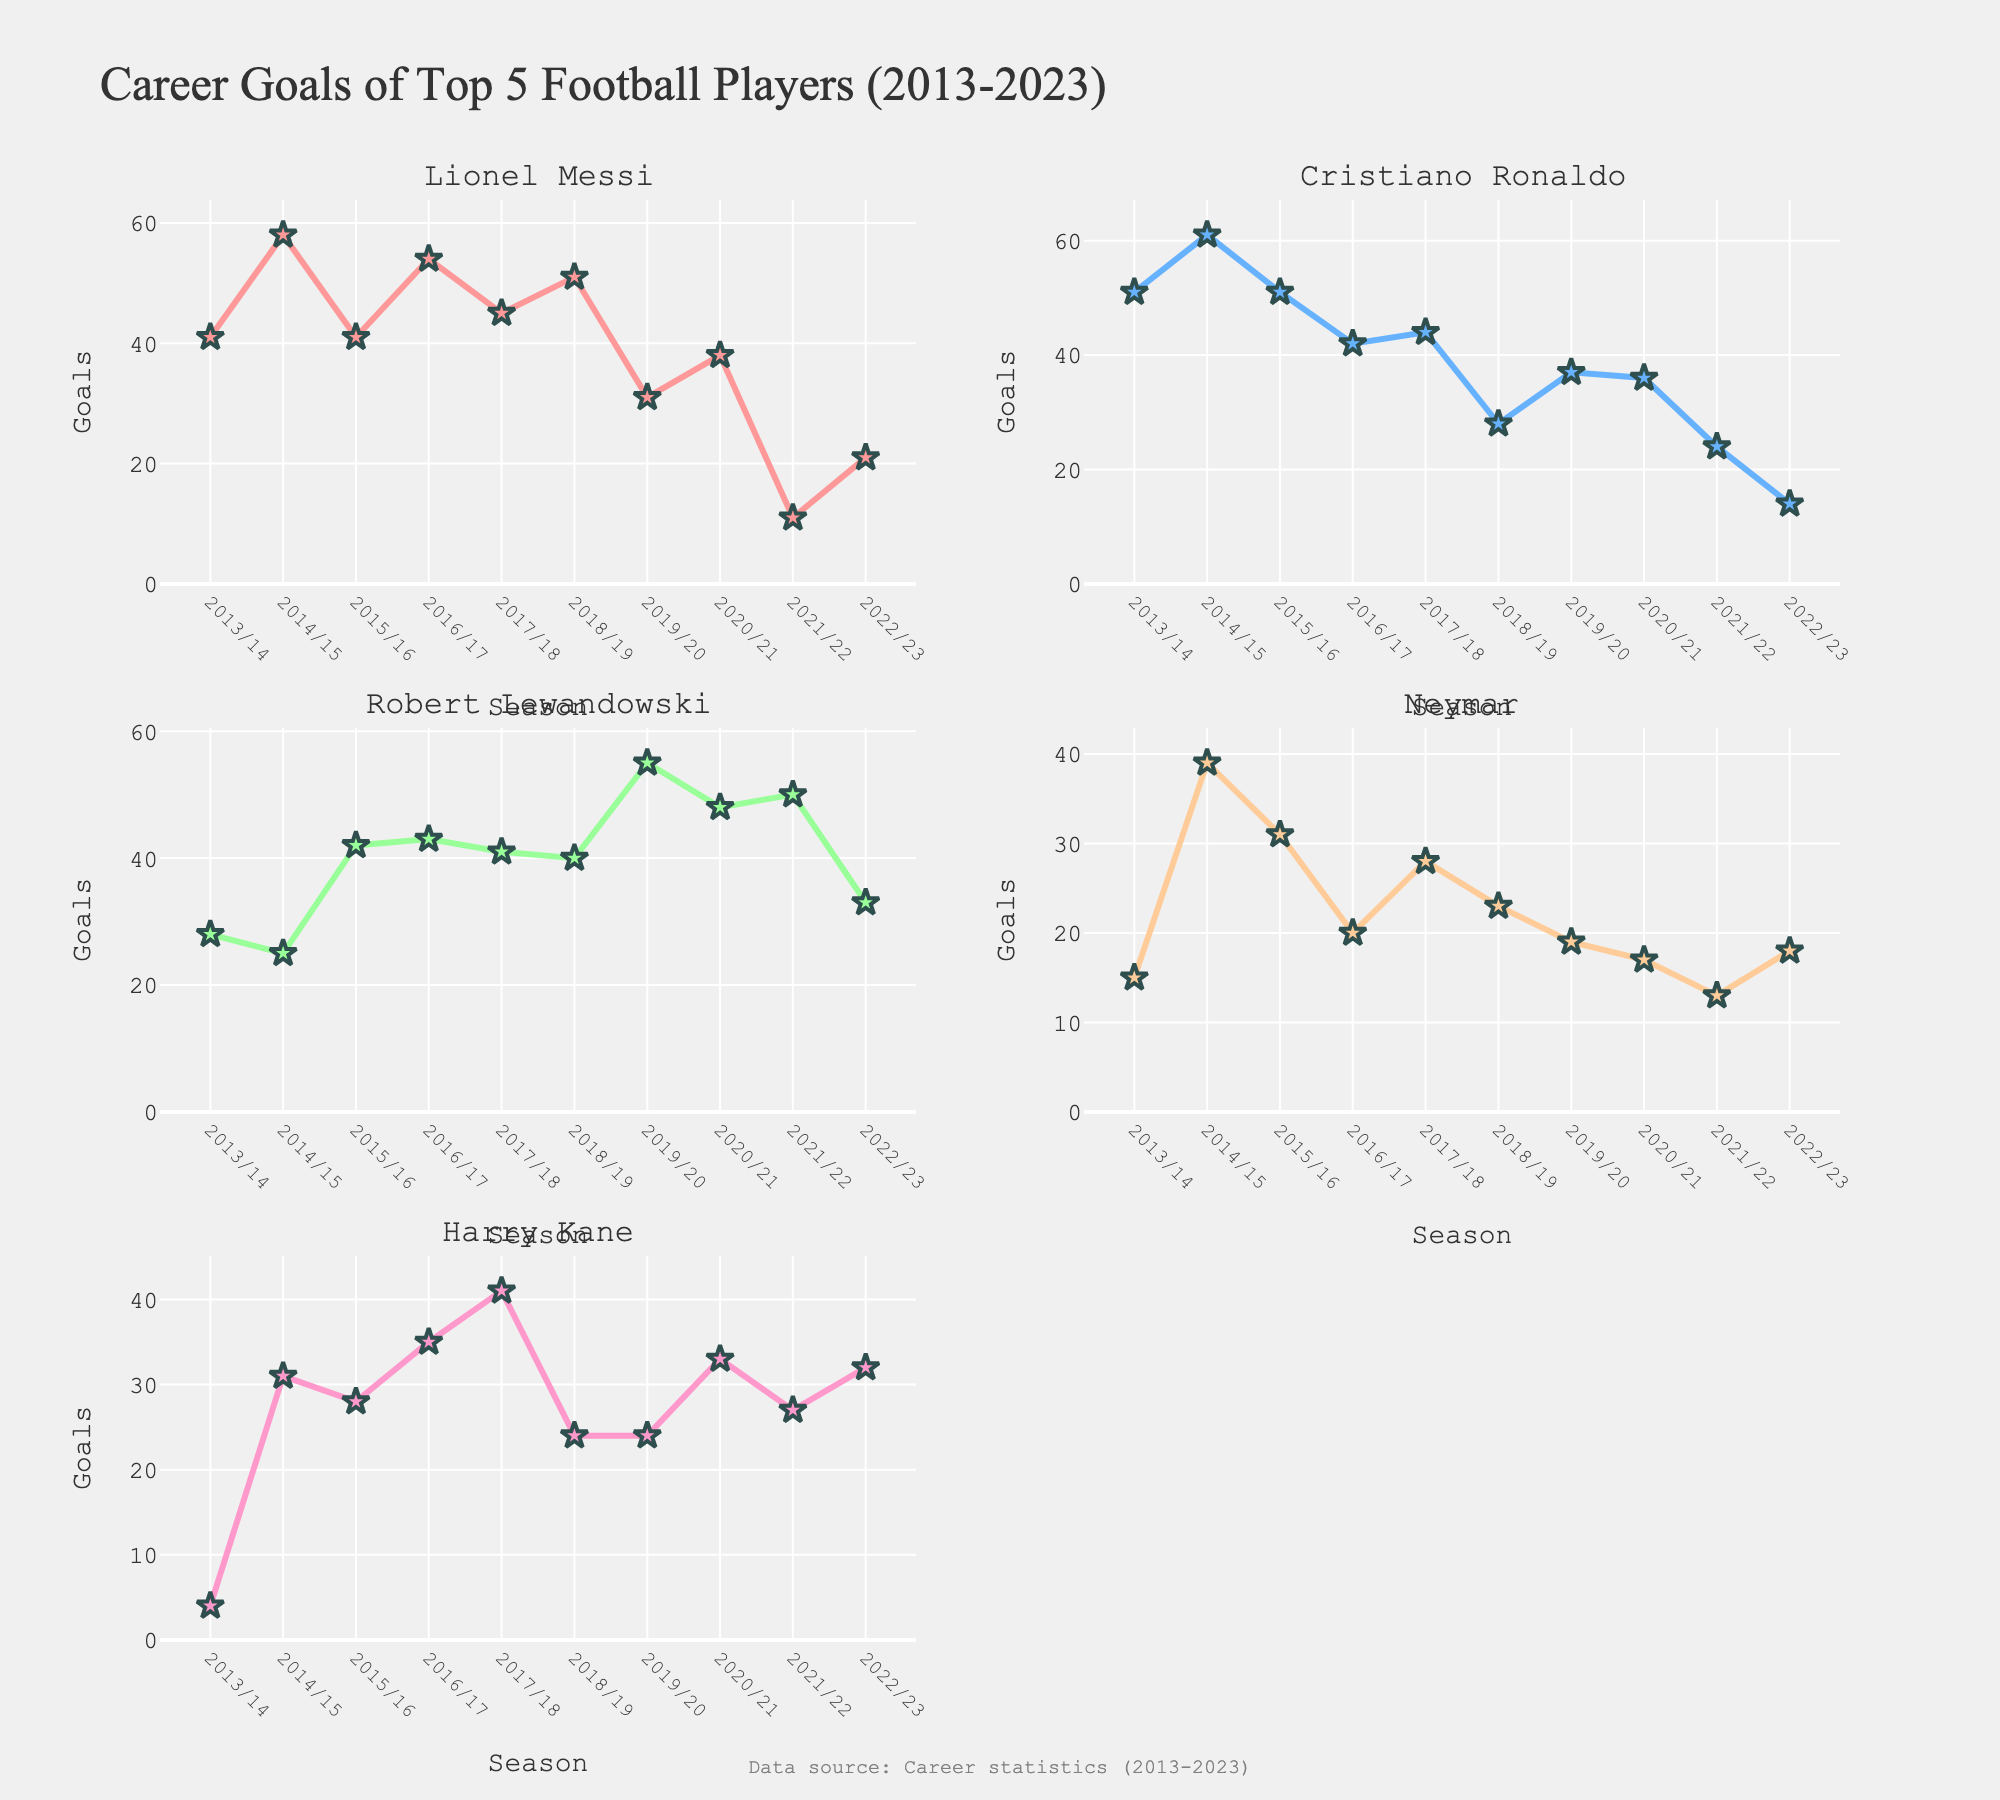What is the title of the figure? The title of the figure is displayed at the top of the plot and reads "Distribution of Joint Infrastructure Projects with Neighboring Countries".
Answer: Distribution of Joint Infrastructure Projects with Neighboring Countries Which project in China has the highest investment? The China subplot shows two projects with their corresponding investment amounts. The project "High-speed Rail Link" has an investment of 5200 million USD, which is the highest among the projects listed for China.
Answer: High-speed Rail Link How many countries have projects listed in the figure? The figure has several subplots, each dedicated to a different country. By counting the subplots, we can identify that there are five countries listed: China, Vietnam, Laos, Thailand, and Myanmar.
Answer: Five What is the sum of the investment amounts for projects in Vietnam? Vietnam has two projects listed: "Mekong Delta Bridge" with an investment of 450 million USD and "Joint Industrial Park" with 320 million USD. Adding these amounts gives 450 + 320 = 770 million USD.
Answer: 770 million USD Which country has the project with the lowest investment amount and what is that project? By examining the investment amounts across all subplots, we can see that the project "Joint Industrial Park" in Vietnam has an investment of 320 million USD, which is the lowest among all projects listed in the figure.
Answer: Vietnam, Joint Industrial Park Compare the investments in hydroelectric projects between Laos and Myanmar. Which country has the higher investment, and by how much? Laos has the "Hydroelectric Dam" project with an investment of 980 million USD, while Myanmar does not have any hydroelectric project listed. Therefore, Laos has a higher investment in this category by 980 million USD.
Answer: Laos, 980 million USD What is the average investment amount for projects in Thailand? Thailand has two projects listed: "Deep-sea Port" with an investment of 1100 million USD and "Highway Network" with 890 million USD. The sum is 1100 + 890 = 1990 million USD. Dividing this sum by the number of projects (2) gives the average investment: 1990 / 2 = 995 million USD.
Answer: 995 million USD Between China and Thailand, which country has a higher total investment amount in the listed projects? Summing the investment amounts for China: 5200 (High-speed Rail Link) + 1800 (Cross-border Power Grid) = 7000 million USD. Summing the investment amounts for Thailand: 1100 (Deep-sea Port) + 890 (Highway Network) = 1990 million USD. Comparing these totals, China has a higher total investment amount.
Answer: China How does the investment in Myanmar's Natural Gas Pipeline compare to the average project investment in the entire figure? First, sum the investment amounts for all projects: 5200 (China) + 1800 (China) + 450 (Vietnam) + 320 (Vietnam) + 980 (Laos) + 670 (Laos) + 1100 (Thailand) + 890 (Thailand) + 720 (Myanmar) + 380 (Myanmar) = 14510 million USD. There are 10 projects in total, so the average investment is 14510 / 10 = 1451 million USD. The investment in Myanmar's Natural Gas Pipeline is 720 million USD, which is less than the average investment of 1451 million USD.
Answer: Less 